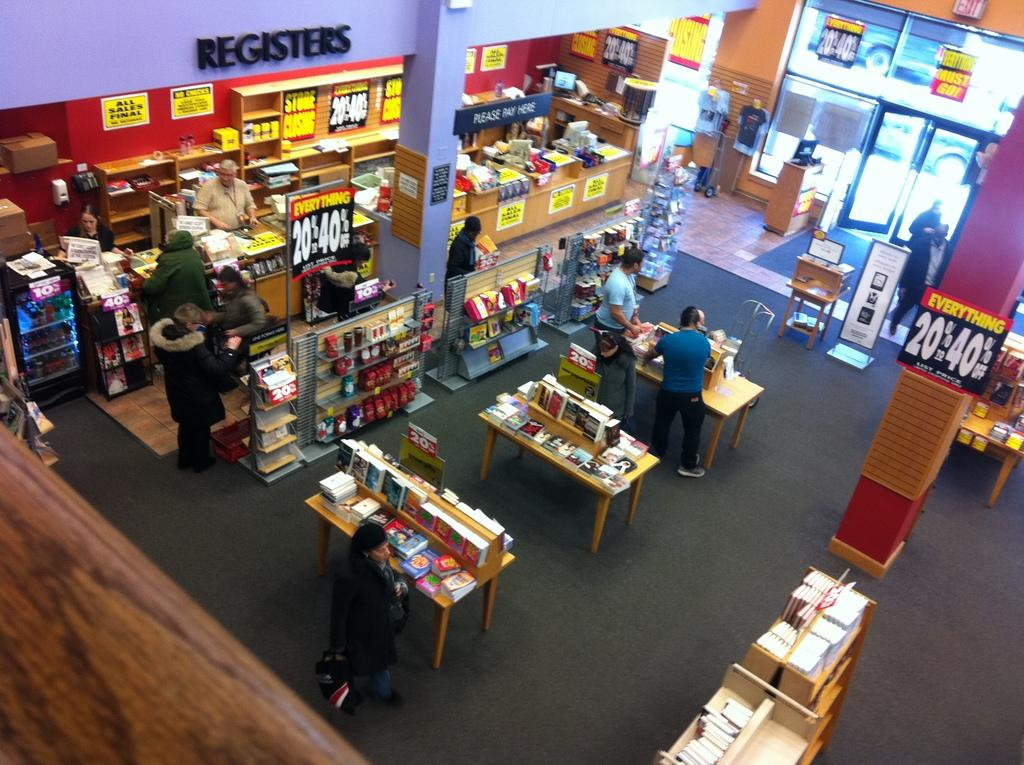Provide a one-sentence caption for the provided image. the inside of a store with a section specifically for registers. 